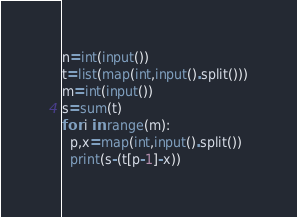Convert code to text. <code><loc_0><loc_0><loc_500><loc_500><_Python_>n=int(input())
t=list(map(int,input().split()))
m=int(input())
s=sum(t)
for i in range(m):
  p,x=map(int,input().split())
  print(s-(t[p-1]-x))</code> 